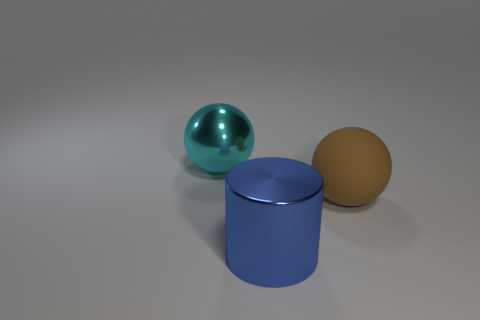How does the lighting in the scene affect the appearance of the objects? The lighting in the scene enhances the objects by creating distinct highlights and shadows, which contributes to their three-dimensional appearance. The reflective surfaces, like that of the sphere on the left, bounce light around and highlight its curvature, while the matte surface of the sphere on the right absorbs light, giving it a flatter appearance. 